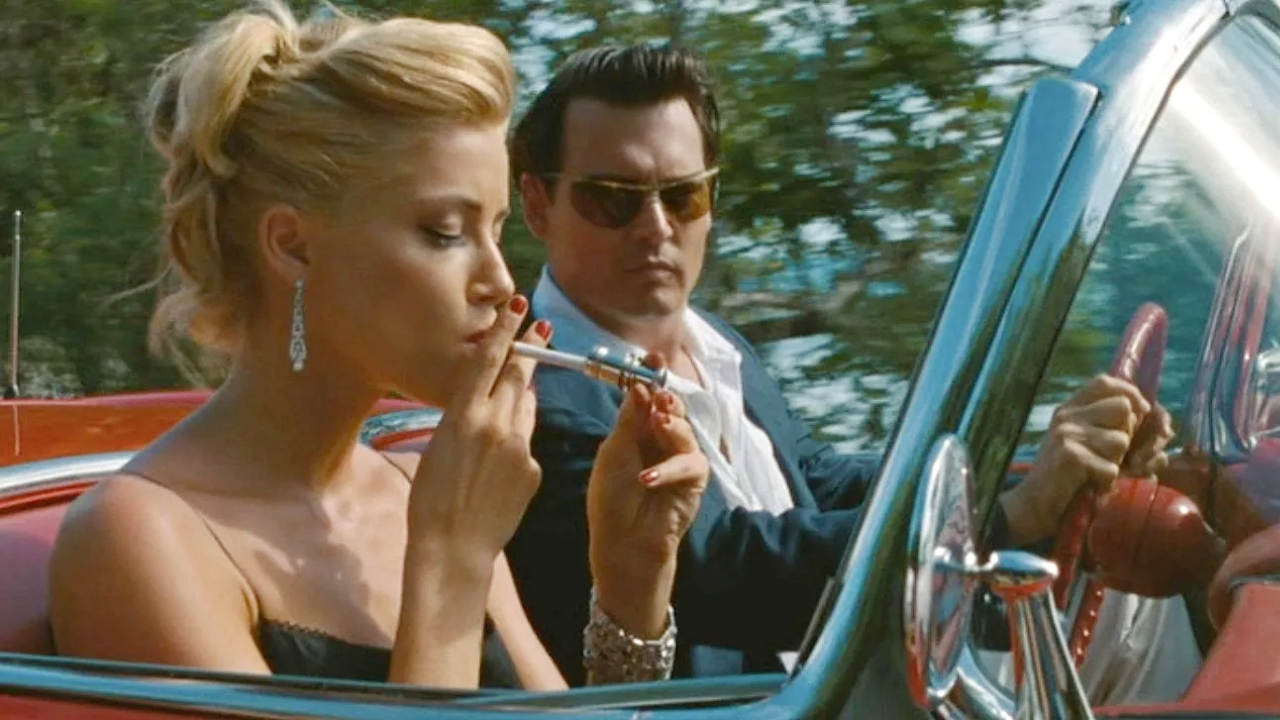How does the setting contribute to the atmosphere of the scene? The lush greenery surrounding the red convertible car establishes a serene yet slightly secretive atmosphere, which complements the private and intense conversation likely happening between the characters. The contrast between the vivid car color and the natural setting emphasizes the characters’ intrusion into a more tranquil environment, aligning with themes of disruption and adventure found in the movie. What might be the significance of the choice of a red car in this scene? The red car could symbolize passion, danger, or a pivotal change in the storyline. It grabs attention, suggesting that the characters are ready to embark on a significant journey or confrontation. Moreover, red often represents deep emotions, which may hint at the underlying tensions or evolving relationships in the film's plot. 